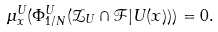<formula> <loc_0><loc_0><loc_500><loc_500>\mu ^ { U } _ { x } ( \Phi ^ { U } _ { 1 / N } ( \mathcal { Z } _ { U } \cap \mathcal { F } | U ( x ) ) ) = 0 .</formula> 